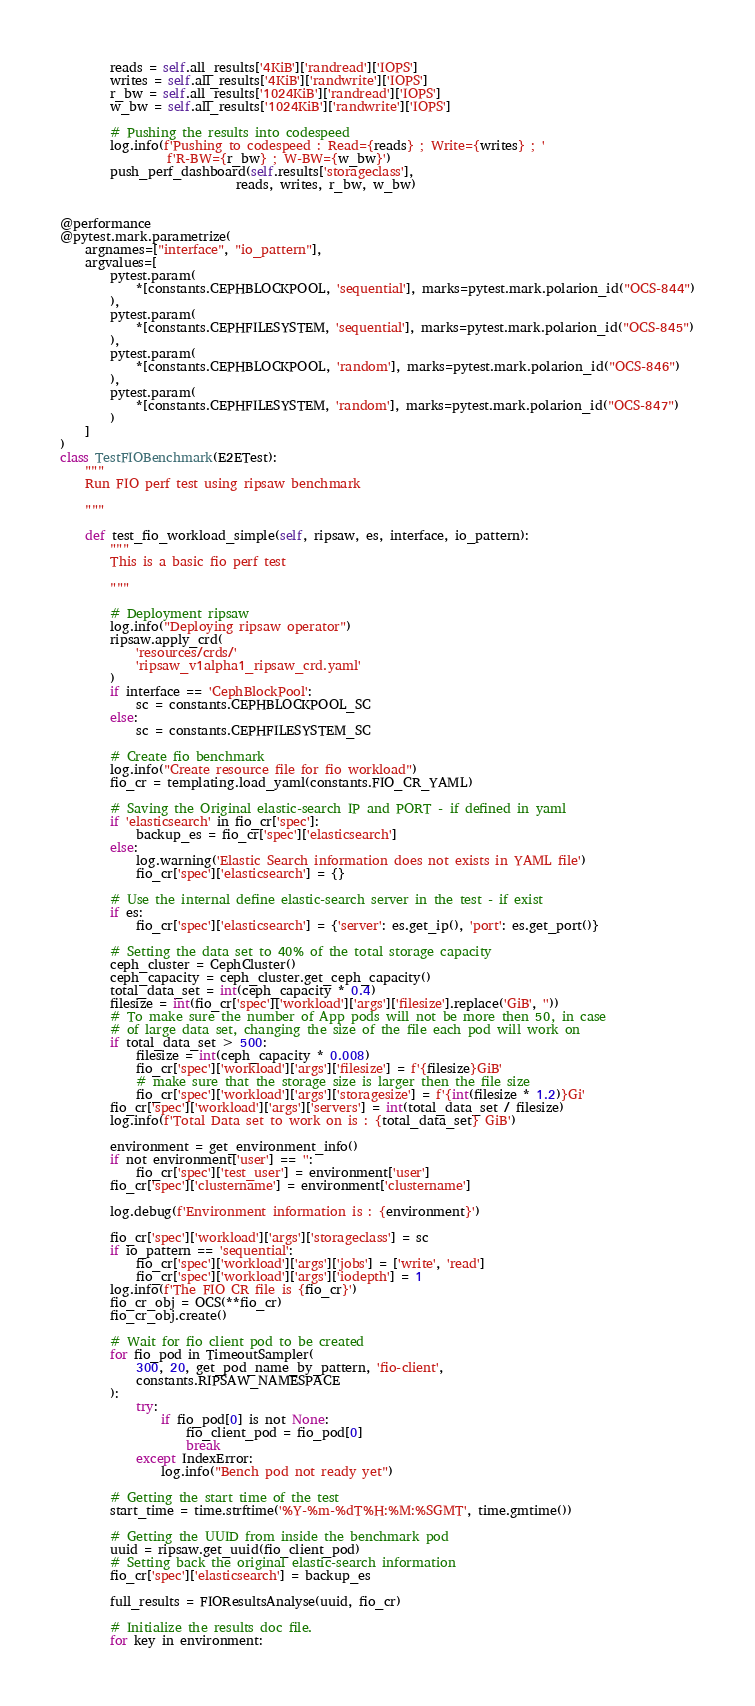Convert code to text. <code><loc_0><loc_0><loc_500><loc_500><_Python_>        reads = self.all_results['4KiB']['randread']['IOPS']
        writes = self.all_results['4KiB']['randwrite']['IOPS']
        r_bw = self.all_results['1024KiB']['randread']['IOPS']
        w_bw = self.all_results['1024KiB']['randwrite']['IOPS']

        # Pushing the results into codespeed
        log.info(f'Pushing to codespeed : Read={reads} ; Write={writes} ; '
                 f'R-BW={r_bw} ; W-BW={w_bw}')
        push_perf_dashboard(self.results['storageclass'],
                            reads, writes, r_bw, w_bw)


@performance
@pytest.mark.parametrize(
    argnames=["interface", "io_pattern"],
    argvalues=[
        pytest.param(
            *[constants.CEPHBLOCKPOOL, 'sequential'], marks=pytest.mark.polarion_id("OCS-844")
        ),
        pytest.param(
            *[constants.CEPHFILESYSTEM, 'sequential'], marks=pytest.mark.polarion_id("OCS-845")
        ),
        pytest.param(
            *[constants.CEPHBLOCKPOOL, 'random'], marks=pytest.mark.polarion_id("OCS-846")
        ),
        pytest.param(
            *[constants.CEPHFILESYSTEM, 'random'], marks=pytest.mark.polarion_id("OCS-847")
        )
    ]
)
class TestFIOBenchmark(E2ETest):
    """
    Run FIO perf test using ripsaw benchmark

    """

    def test_fio_workload_simple(self, ripsaw, es, interface, io_pattern):
        """
        This is a basic fio perf test

        """

        # Deployment ripsaw
        log.info("Deploying ripsaw operator")
        ripsaw.apply_crd(
            'resources/crds/'
            'ripsaw_v1alpha1_ripsaw_crd.yaml'
        )
        if interface == 'CephBlockPool':
            sc = constants.CEPHBLOCKPOOL_SC
        else:
            sc = constants.CEPHFILESYSTEM_SC

        # Create fio benchmark
        log.info("Create resource file for fio workload")
        fio_cr = templating.load_yaml(constants.FIO_CR_YAML)

        # Saving the Original elastic-search IP and PORT - if defined in yaml
        if 'elasticsearch' in fio_cr['spec']:
            backup_es = fio_cr['spec']['elasticsearch']
        else:
            log.warning('Elastic Search information does not exists in YAML file')
            fio_cr['spec']['elasticsearch'] = {}

        # Use the internal define elastic-search server in the test - if exist
        if es:
            fio_cr['spec']['elasticsearch'] = {'server': es.get_ip(), 'port': es.get_port()}

        # Setting the data set to 40% of the total storage capacity
        ceph_cluster = CephCluster()
        ceph_capacity = ceph_cluster.get_ceph_capacity()
        total_data_set = int(ceph_capacity * 0.4)
        filesize = int(fio_cr['spec']['workload']['args']['filesize'].replace('GiB', ''))
        # To make sure the number of App pods will not be more then 50, in case
        # of large data set, changing the size of the file each pod will work on
        if total_data_set > 500:
            filesize = int(ceph_capacity * 0.008)
            fio_cr['spec']['workload']['args']['filesize'] = f'{filesize}GiB'
            # make sure that the storage size is larger then the file size
            fio_cr['spec']['workload']['args']['storagesize'] = f'{int(filesize * 1.2)}Gi'
        fio_cr['spec']['workload']['args']['servers'] = int(total_data_set / filesize)
        log.info(f'Total Data set to work on is : {total_data_set} GiB')

        environment = get_environment_info()
        if not environment['user'] == '':
            fio_cr['spec']['test_user'] = environment['user']
        fio_cr['spec']['clustername'] = environment['clustername']

        log.debug(f'Environment information is : {environment}')

        fio_cr['spec']['workload']['args']['storageclass'] = sc
        if io_pattern == 'sequential':
            fio_cr['spec']['workload']['args']['jobs'] = ['write', 'read']
            fio_cr['spec']['workload']['args']['iodepth'] = 1
        log.info(f'The FIO CR file is {fio_cr}')
        fio_cr_obj = OCS(**fio_cr)
        fio_cr_obj.create()

        # Wait for fio client pod to be created
        for fio_pod in TimeoutSampler(
            300, 20, get_pod_name_by_pattern, 'fio-client',
            constants.RIPSAW_NAMESPACE
        ):
            try:
                if fio_pod[0] is not None:
                    fio_client_pod = fio_pod[0]
                    break
            except IndexError:
                log.info("Bench pod not ready yet")

        # Getting the start time of the test
        start_time = time.strftime('%Y-%m-%dT%H:%M:%SGMT', time.gmtime())

        # Getting the UUID from inside the benchmark pod
        uuid = ripsaw.get_uuid(fio_client_pod)
        # Setting back the original elastic-search information
        fio_cr['spec']['elasticsearch'] = backup_es

        full_results = FIOResultsAnalyse(uuid, fio_cr)

        # Initialize the results doc file.
        for key in environment:</code> 